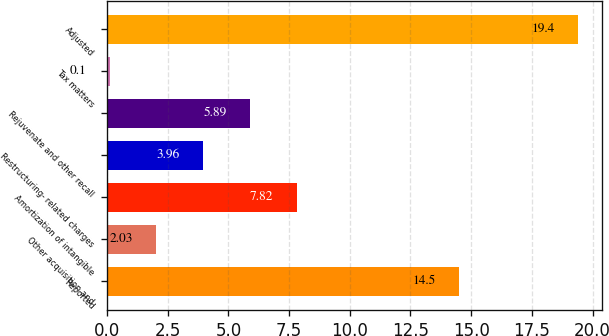<chart> <loc_0><loc_0><loc_500><loc_500><bar_chart><fcel>Reported<fcel>Other acquisition and<fcel>Amortization of intangible<fcel>Restructuring- related charges<fcel>Rejuvenate and other recall<fcel>Tax matters<fcel>Adjusted<nl><fcel>14.5<fcel>2.03<fcel>7.82<fcel>3.96<fcel>5.89<fcel>0.1<fcel>19.4<nl></chart> 